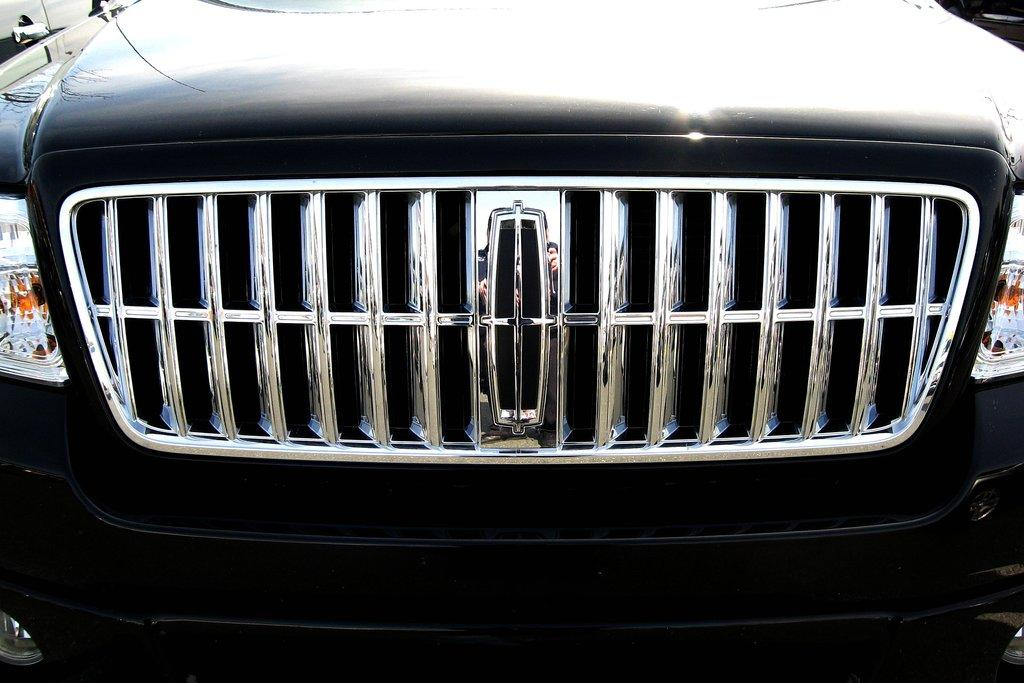What types of objects can be seen in the image? There are vehicles in the image. Can you see a kitten riding on one of the vehicles in the image? There is no kitten present in the image, and therefore it cannot be seen riding on any of the vehicles. 